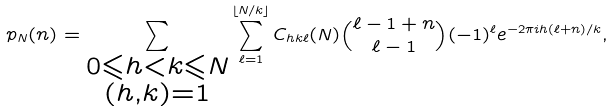Convert formula to latex. <formula><loc_0><loc_0><loc_500><loc_500>p _ { N } ( n ) = \sum _ { \substack { 0 \leqslant h < k \leqslant N \\ ( h , k ) = 1 } } \sum _ { \ell = 1 } ^ { \lfloor N / k \rfloor } C _ { h k \ell } ( N ) \binom { \ell - 1 + n } { \ell - 1 } ( - 1 ) ^ { \ell } e ^ { - 2 \pi i h ( \ell + n ) / k } ,</formula> 